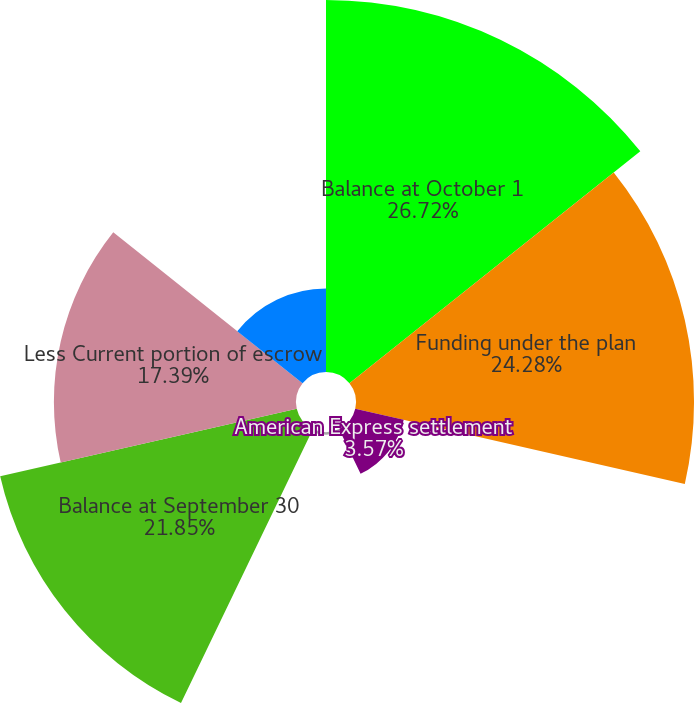Convert chart. <chart><loc_0><loc_0><loc_500><loc_500><pie_chart><fcel>Balance at October 1<fcel>Funding under the plan<fcel>American Express settlement<fcel>Interest earned less<fcel>Balance at September 30<fcel>Less Current portion of escrow<fcel>Long-term portion of escrow<nl><fcel>26.72%<fcel>24.28%<fcel>3.57%<fcel>0.19%<fcel>21.85%<fcel>17.39%<fcel>6.0%<nl></chart> 